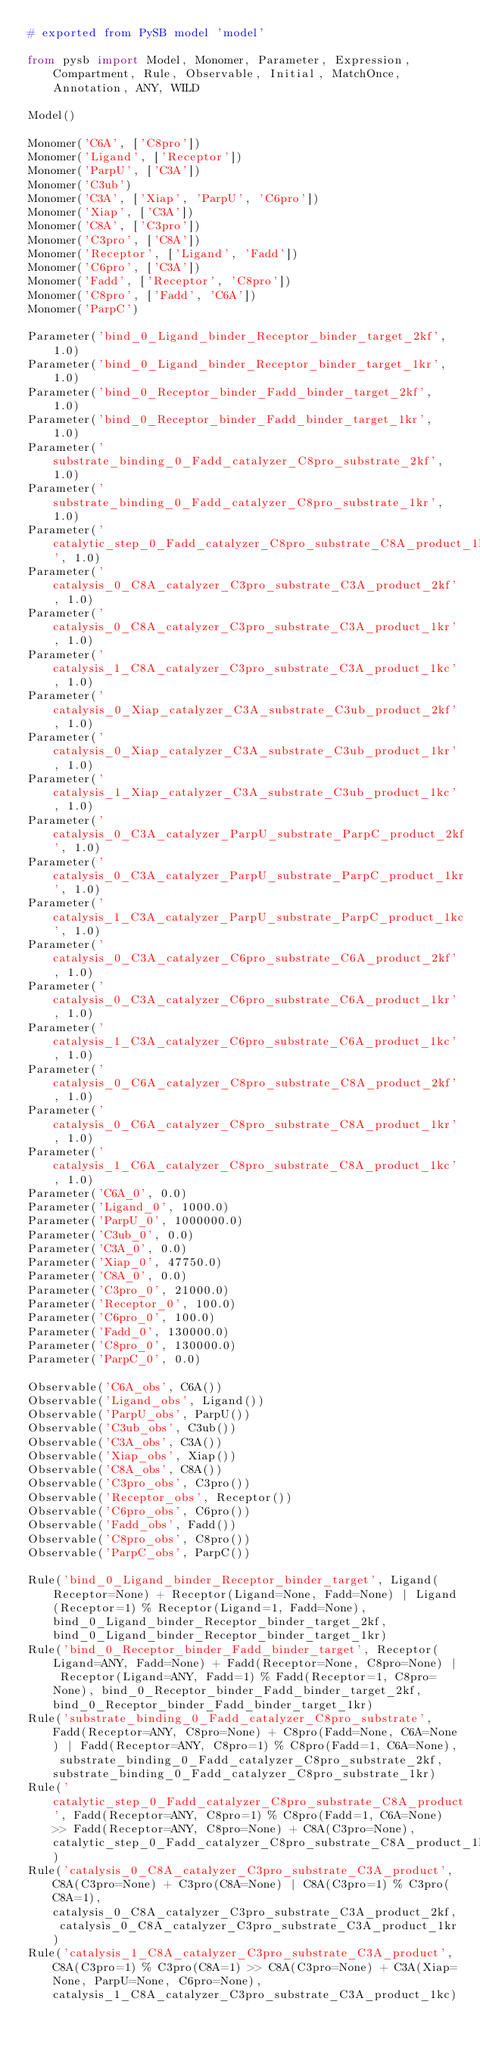Convert code to text. <code><loc_0><loc_0><loc_500><loc_500><_Python_># exported from PySB model 'model'

from pysb import Model, Monomer, Parameter, Expression, Compartment, Rule, Observable, Initial, MatchOnce, Annotation, ANY, WILD

Model()

Monomer('C6A', ['C8pro'])
Monomer('Ligand', ['Receptor'])
Monomer('ParpU', ['C3A'])
Monomer('C3ub')
Monomer('C3A', ['Xiap', 'ParpU', 'C6pro'])
Monomer('Xiap', ['C3A'])
Monomer('C8A', ['C3pro'])
Monomer('C3pro', ['C8A'])
Monomer('Receptor', ['Ligand', 'Fadd'])
Monomer('C6pro', ['C3A'])
Monomer('Fadd', ['Receptor', 'C8pro'])
Monomer('C8pro', ['Fadd', 'C6A'])
Monomer('ParpC')

Parameter('bind_0_Ligand_binder_Receptor_binder_target_2kf', 1.0)
Parameter('bind_0_Ligand_binder_Receptor_binder_target_1kr', 1.0)
Parameter('bind_0_Receptor_binder_Fadd_binder_target_2kf', 1.0)
Parameter('bind_0_Receptor_binder_Fadd_binder_target_1kr', 1.0)
Parameter('substrate_binding_0_Fadd_catalyzer_C8pro_substrate_2kf', 1.0)
Parameter('substrate_binding_0_Fadd_catalyzer_C8pro_substrate_1kr', 1.0)
Parameter('catalytic_step_0_Fadd_catalyzer_C8pro_substrate_C8A_product_1kc', 1.0)
Parameter('catalysis_0_C8A_catalyzer_C3pro_substrate_C3A_product_2kf', 1.0)
Parameter('catalysis_0_C8A_catalyzer_C3pro_substrate_C3A_product_1kr', 1.0)
Parameter('catalysis_1_C8A_catalyzer_C3pro_substrate_C3A_product_1kc', 1.0)
Parameter('catalysis_0_Xiap_catalyzer_C3A_substrate_C3ub_product_2kf', 1.0)
Parameter('catalysis_0_Xiap_catalyzer_C3A_substrate_C3ub_product_1kr', 1.0)
Parameter('catalysis_1_Xiap_catalyzer_C3A_substrate_C3ub_product_1kc', 1.0)
Parameter('catalysis_0_C3A_catalyzer_ParpU_substrate_ParpC_product_2kf', 1.0)
Parameter('catalysis_0_C3A_catalyzer_ParpU_substrate_ParpC_product_1kr', 1.0)
Parameter('catalysis_1_C3A_catalyzer_ParpU_substrate_ParpC_product_1kc', 1.0)
Parameter('catalysis_0_C3A_catalyzer_C6pro_substrate_C6A_product_2kf', 1.0)
Parameter('catalysis_0_C3A_catalyzer_C6pro_substrate_C6A_product_1kr', 1.0)
Parameter('catalysis_1_C3A_catalyzer_C6pro_substrate_C6A_product_1kc', 1.0)
Parameter('catalysis_0_C6A_catalyzer_C8pro_substrate_C8A_product_2kf', 1.0)
Parameter('catalysis_0_C6A_catalyzer_C8pro_substrate_C8A_product_1kr', 1.0)
Parameter('catalysis_1_C6A_catalyzer_C8pro_substrate_C8A_product_1kc', 1.0)
Parameter('C6A_0', 0.0)
Parameter('Ligand_0', 1000.0)
Parameter('ParpU_0', 1000000.0)
Parameter('C3ub_0', 0.0)
Parameter('C3A_0', 0.0)
Parameter('Xiap_0', 47750.0)
Parameter('C8A_0', 0.0)
Parameter('C3pro_0', 21000.0)
Parameter('Receptor_0', 100.0)
Parameter('C6pro_0', 100.0)
Parameter('Fadd_0', 130000.0)
Parameter('C8pro_0', 130000.0)
Parameter('ParpC_0', 0.0)

Observable('C6A_obs', C6A())
Observable('Ligand_obs', Ligand())
Observable('ParpU_obs', ParpU())
Observable('C3ub_obs', C3ub())
Observable('C3A_obs', C3A())
Observable('Xiap_obs', Xiap())
Observable('C8A_obs', C8A())
Observable('C3pro_obs', C3pro())
Observable('Receptor_obs', Receptor())
Observable('C6pro_obs', C6pro())
Observable('Fadd_obs', Fadd())
Observable('C8pro_obs', C8pro())
Observable('ParpC_obs', ParpC())

Rule('bind_0_Ligand_binder_Receptor_binder_target', Ligand(Receptor=None) + Receptor(Ligand=None, Fadd=None) | Ligand(Receptor=1) % Receptor(Ligand=1, Fadd=None), bind_0_Ligand_binder_Receptor_binder_target_2kf, bind_0_Ligand_binder_Receptor_binder_target_1kr)
Rule('bind_0_Receptor_binder_Fadd_binder_target', Receptor(Ligand=ANY, Fadd=None) + Fadd(Receptor=None, C8pro=None) | Receptor(Ligand=ANY, Fadd=1) % Fadd(Receptor=1, C8pro=None), bind_0_Receptor_binder_Fadd_binder_target_2kf, bind_0_Receptor_binder_Fadd_binder_target_1kr)
Rule('substrate_binding_0_Fadd_catalyzer_C8pro_substrate', Fadd(Receptor=ANY, C8pro=None) + C8pro(Fadd=None, C6A=None) | Fadd(Receptor=ANY, C8pro=1) % C8pro(Fadd=1, C6A=None), substrate_binding_0_Fadd_catalyzer_C8pro_substrate_2kf, substrate_binding_0_Fadd_catalyzer_C8pro_substrate_1kr)
Rule('catalytic_step_0_Fadd_catalyzer_C8pro_substrate_C8A_product', Fadd(Receptor=ANY, C8pro=1) % C8pro(Fadd=1, C6A=None) >> Fadd(Receptor=ANY, C8pro=None) + C8A(C3pro=None), catalytic_step_0_Fadd_catalyzer_C8pro_substrate_C8A_product_1kc)
Rule('catalysis_0_C8A_catalyzer_C3pro_substrate_C3A_product', C8A(C3pro=None) + C3pro(C8A=None) | C8A(C3pro=1) % C3pro(C8A=1), catalysis_0_C8A_catalyzer_C3pro_substrate_C3A_product_2kf, catalysis_0_C8A_catalyzer_C3pro_substrate_C3A_product_1kr)
Rule('catalysis_1_C8A_catalyzer_C3pro_substrate_C3A_product', C8A(C3pro=1) % C3pro(C8A=1) >> C8A(C3pro=None) + C3A(Xiap=None, ParpU=None, C6pro=None), catalysis_1_C8A_catalyzer_C3pro_substrate_C3A_product_1kc)</code> 